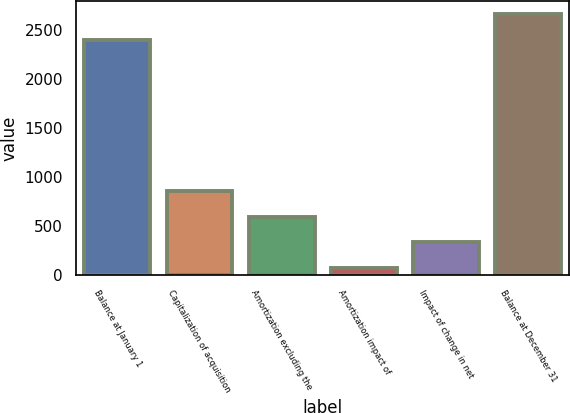Convert chart to OTSL. <chart><loc_0><loc_0><loc_500><loc_500><bar_chart><fcel>Balance at January 1<fcel>Capitalization of acquisition<fcel>Amortization excluding the<fcel>Amortization impact of<fcel>Impact of change in net<fcel>Balance at December 31<nl><fcel>2399<fcel>853.5<fcel>595<fcel>78<fcel>336.5<fcel>2663<nl></chart> 